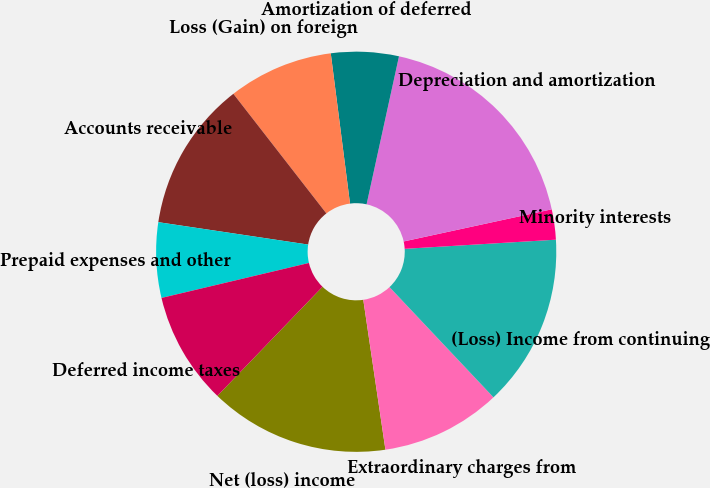Convert chart. <chart><loc_0><loc_0><loc_500><loc_500><pie_chart><fcel>Net (loss) income<fcel>Extraordinary charges from<fcel>(Loss) Income from continuing<fcel>Minority interests<fcel>Depreciation and amortization<fcel>Amortization of deferred<fcel>Loss (Gain) on foreign<fcel>Accounts receivable<fcel>Prepaid expenses and other<fcel>Deferred income taxes<nl><fcel>14.54%<fcel>9.7%<fcel>13.93%<fcel>2.44%<fcel>18.17%<fcel>5.46%<fcel>8.49%<fcel>12.12%<fcel>6.07%<fcel>9.09%<nl></chart> 